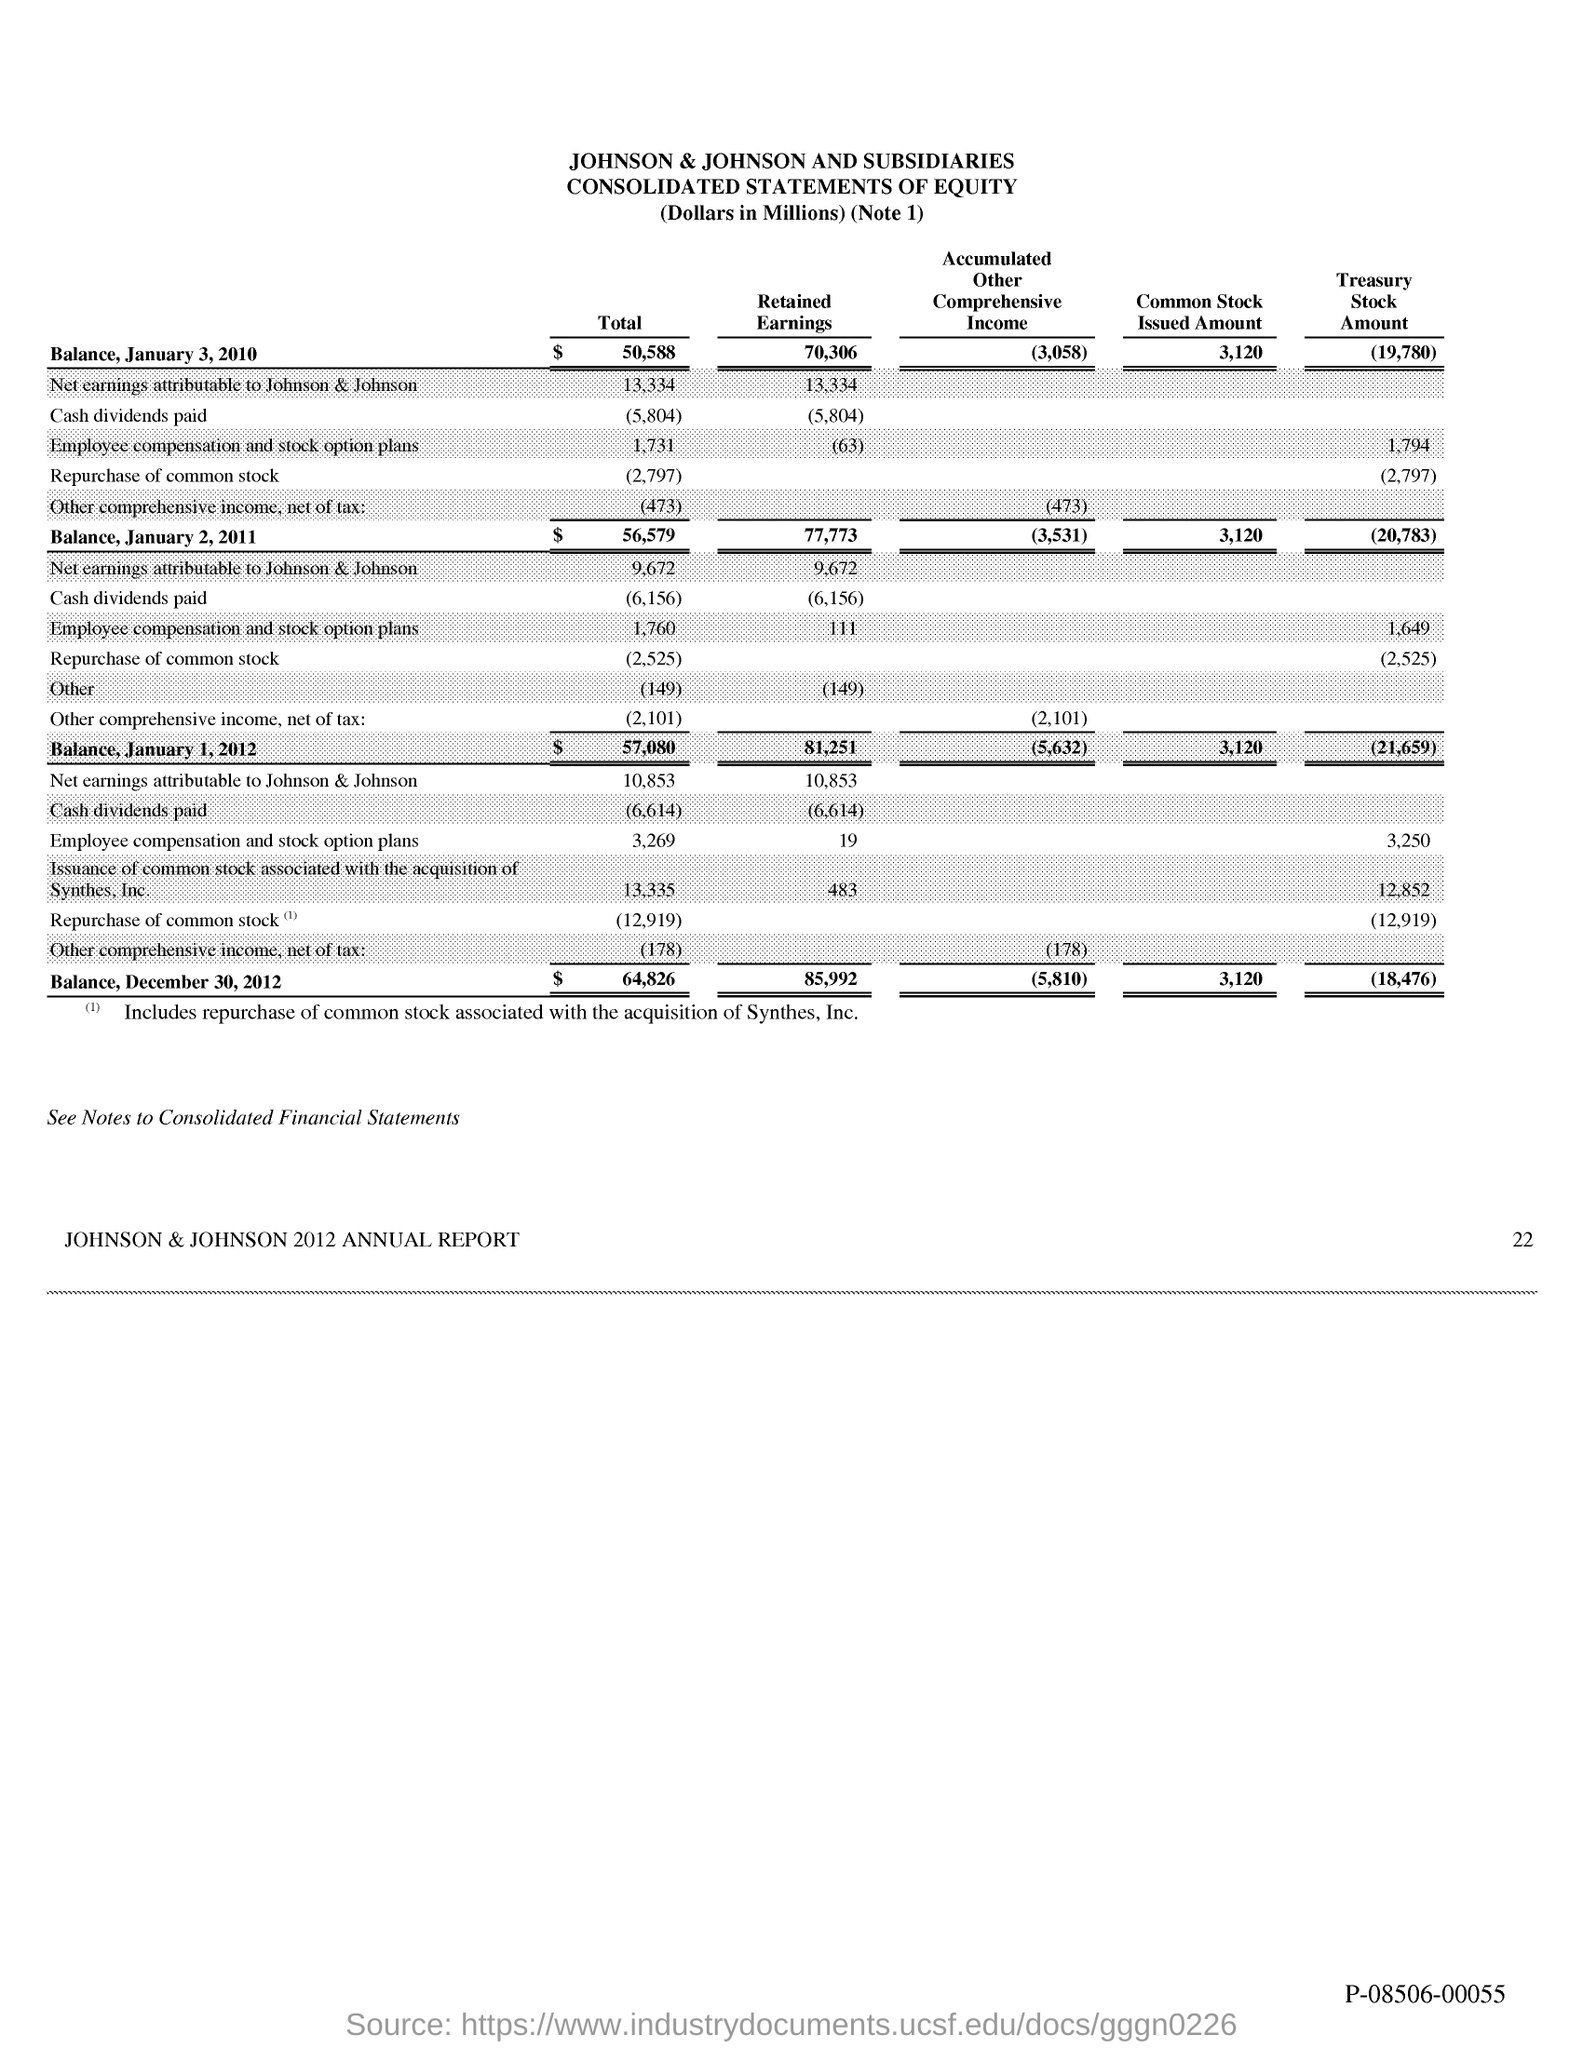Identify some key points in this picture. The total balance on January 2, 2011, was 56,579. The total balance as on December 30, 2012, was $64,826. The common stock issued amount as on January 3, 2010, was 3,120. On January 3, 2010, the retained earnings were 70,306. The total balance as on January 1, 2012, was $57,080. 